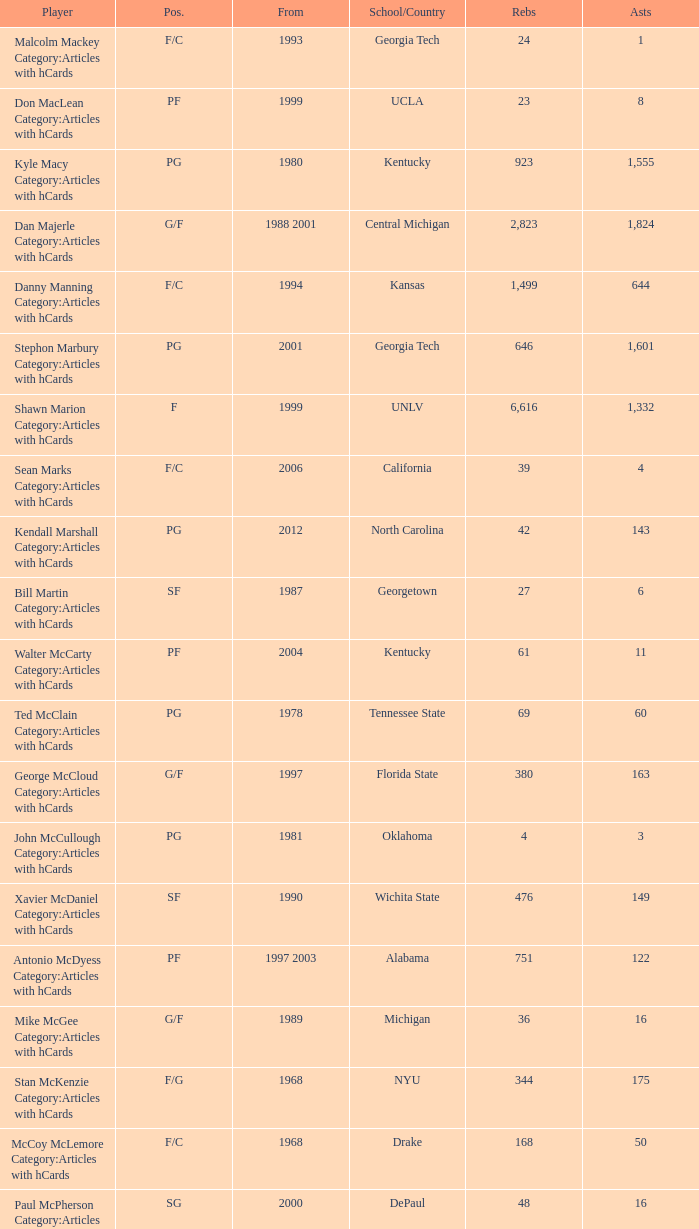In 2000, who recorded the highest number of assists? 16.0. 